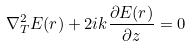Convert formula to latex. <formula><loc_0><loc_0><loc_500><loc_500>\nabla ^ { 2 } _ { T } { E } ( { r } ) + 2 i k \frac { \partial { E } ( { r } ) } { \partial z } = 0</formula> 